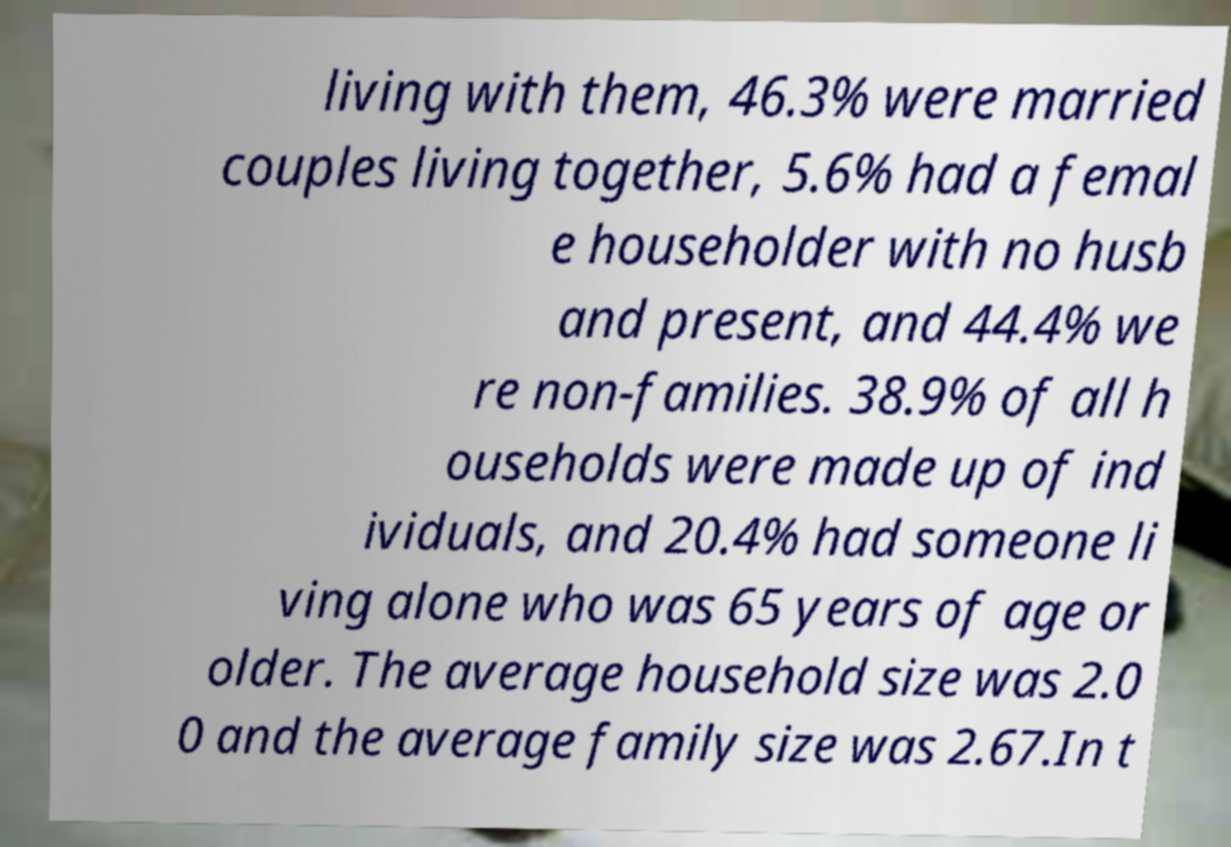Can you accurately transcribe the text from the provided image for me? living with them, 46.3% were married couples living together, 5.6% had a femal e householder with no husb and present, and 44.4% we re non-families. 38.9% of all h ouseholds were made up of ind ividuals, and 20.4% had someone li ving alone who was 65 years of age or older. The average household size was 2.0 0 and the average family size was 2.67.In t 